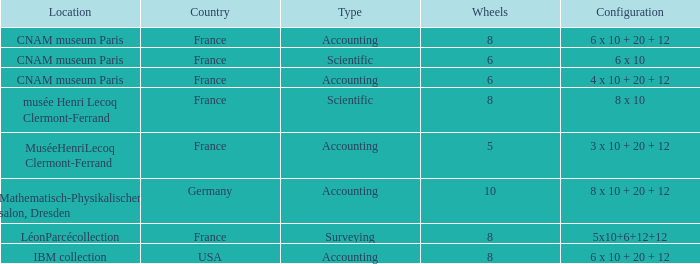What average wheels has accounting as the type, with IBM Collection as the location? 8.0. 